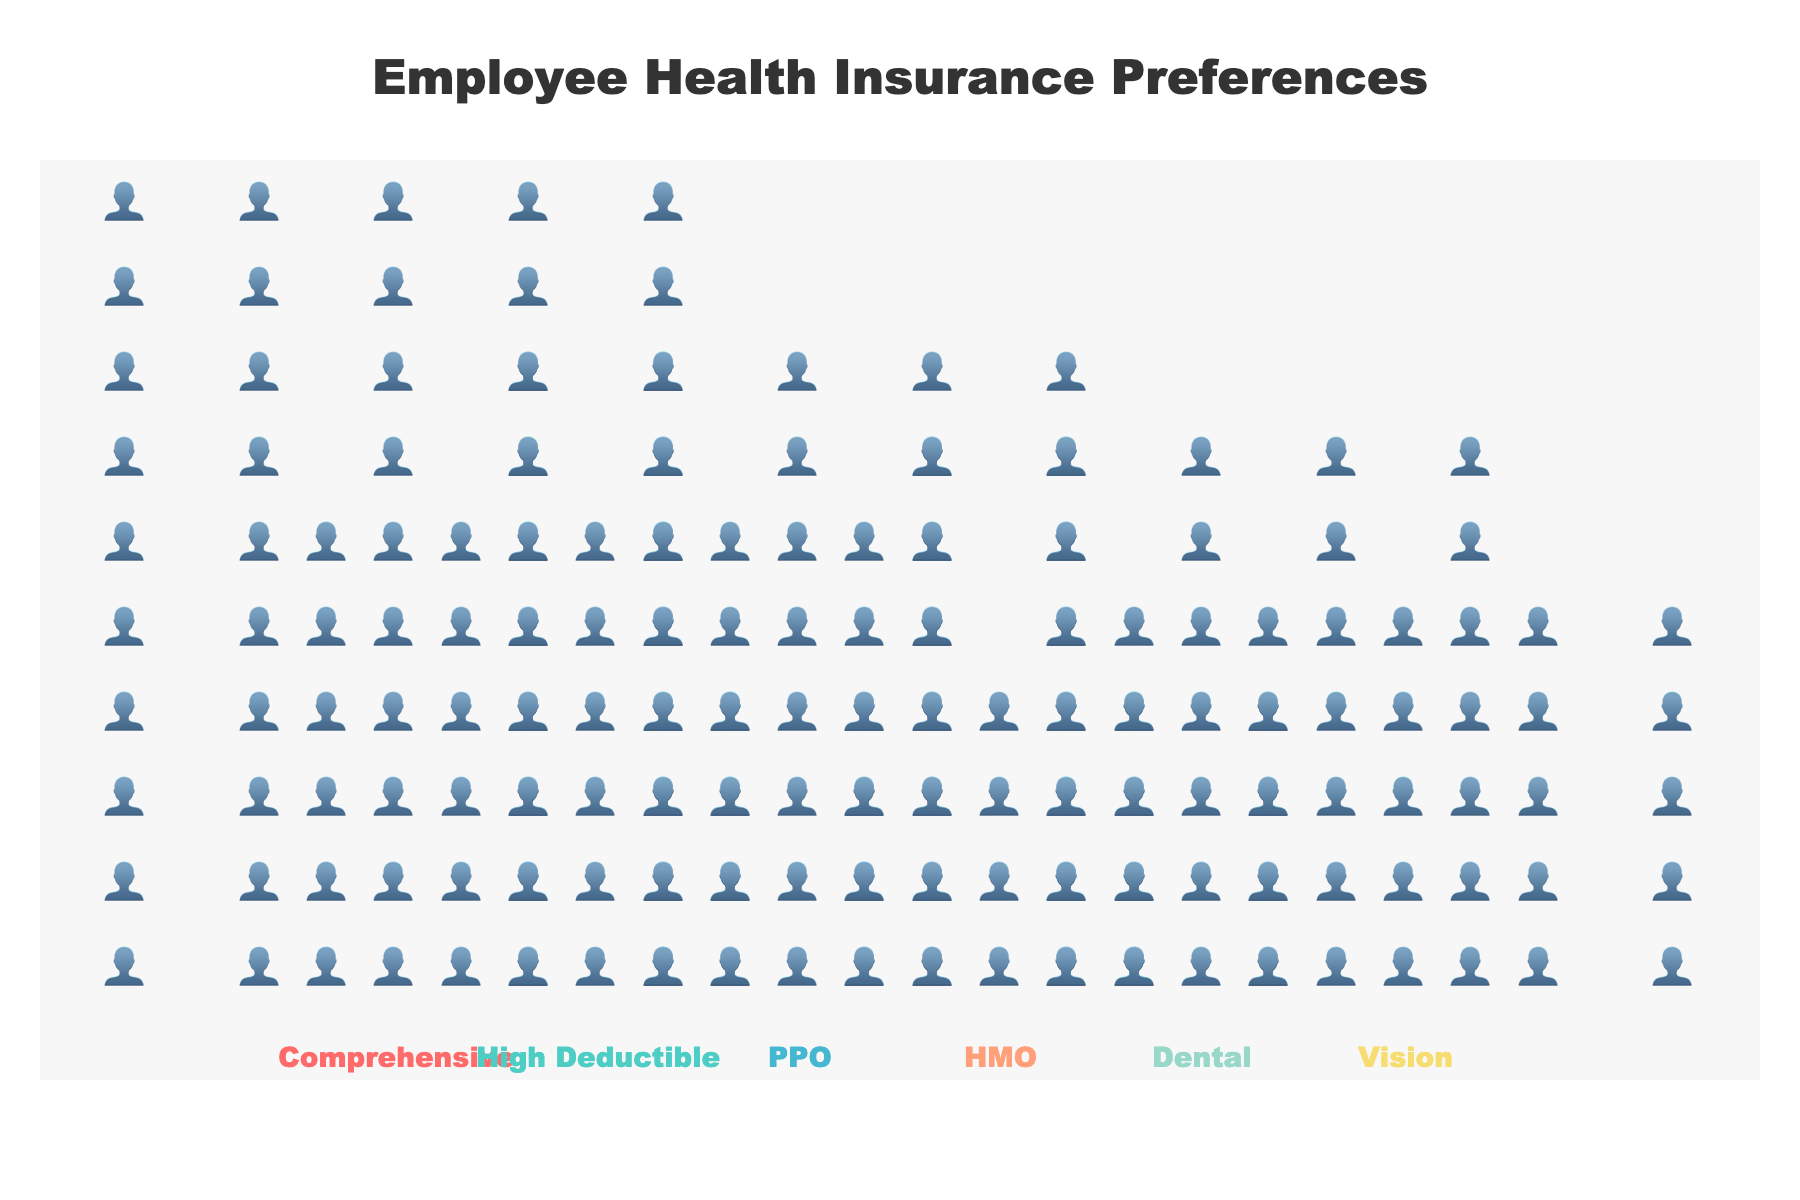How many employees prefer Comprehensive coverage? The figure shows icons representing employee preferences. By counting the icons in the Comprehensive section, you can see 50 icons.
Answer: 50 How many more employees prefer PPO over HMO coverage? To find the difference, look at the counts of employees preferring each coverage type. PPO has 40, and HMO has 20. The difference is 40 - 20.
Answer: 20 Which coverage type is the least preferred by employees? By observing the number of icons for each coverage type, HMO has the fewest icons, indicating it is the least preferred.
Answer: HMO What is the total number of employees represented in the plot? Sum the number of employees preferring each coverage type: 50 (Comprehensive) + 30 (High Deductible) + 40 (PPO) + 20 (HMO) + 35 (Dental) + 25 (Vision) = 200.
Answer: 200 Which two coverage types have a combined preference of 60 employees? Check different combinations of coverage types to see which sum to 60. High Deductible (30) and Vision (25) together equal 55, but Comprehensive (50) and Vision (25) equal 75, so none sum to exactly 60. Therefore, recheck the combinations: High Deductible and Dental together equal 65, also not the correct sum; PPO (40) and HMO (20) equal 60.
Answer: PPO and HMO How many more employees prefer Comprehensive coverage compared to Vision? Look at the counts for Comprehensive and Vision. Comprehensive has 50, and Vision has 25. The difference is 50 - 25.
Answer: 25 What is the average number of employees preferring the given coverage types? Add the total counts and divide by the number of categories: (50 + 30 + 40 + 20 + 35 + 25) / 6. The sum is 200, and dividing by 6 gives approximately 33.33.
Answer: 33.33 Which coverage types have fewer preferences than the average number of employees preferring coverage types? The average number of preferences is about 33.33. The coverage types with fewer are High Deductible (30), HMO (20), and Vision (25).
Answer: High Deductible, HMO, and Vision 